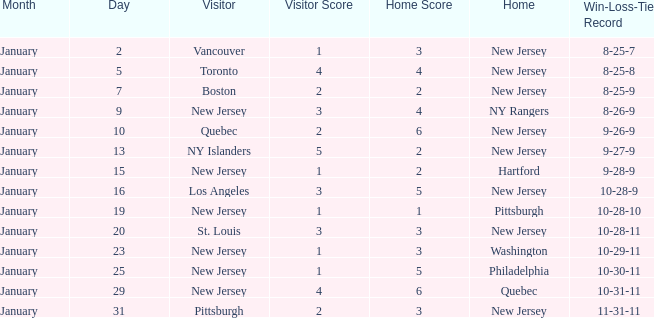What was the home team when the visiting team was Toronto? New Jersey. 